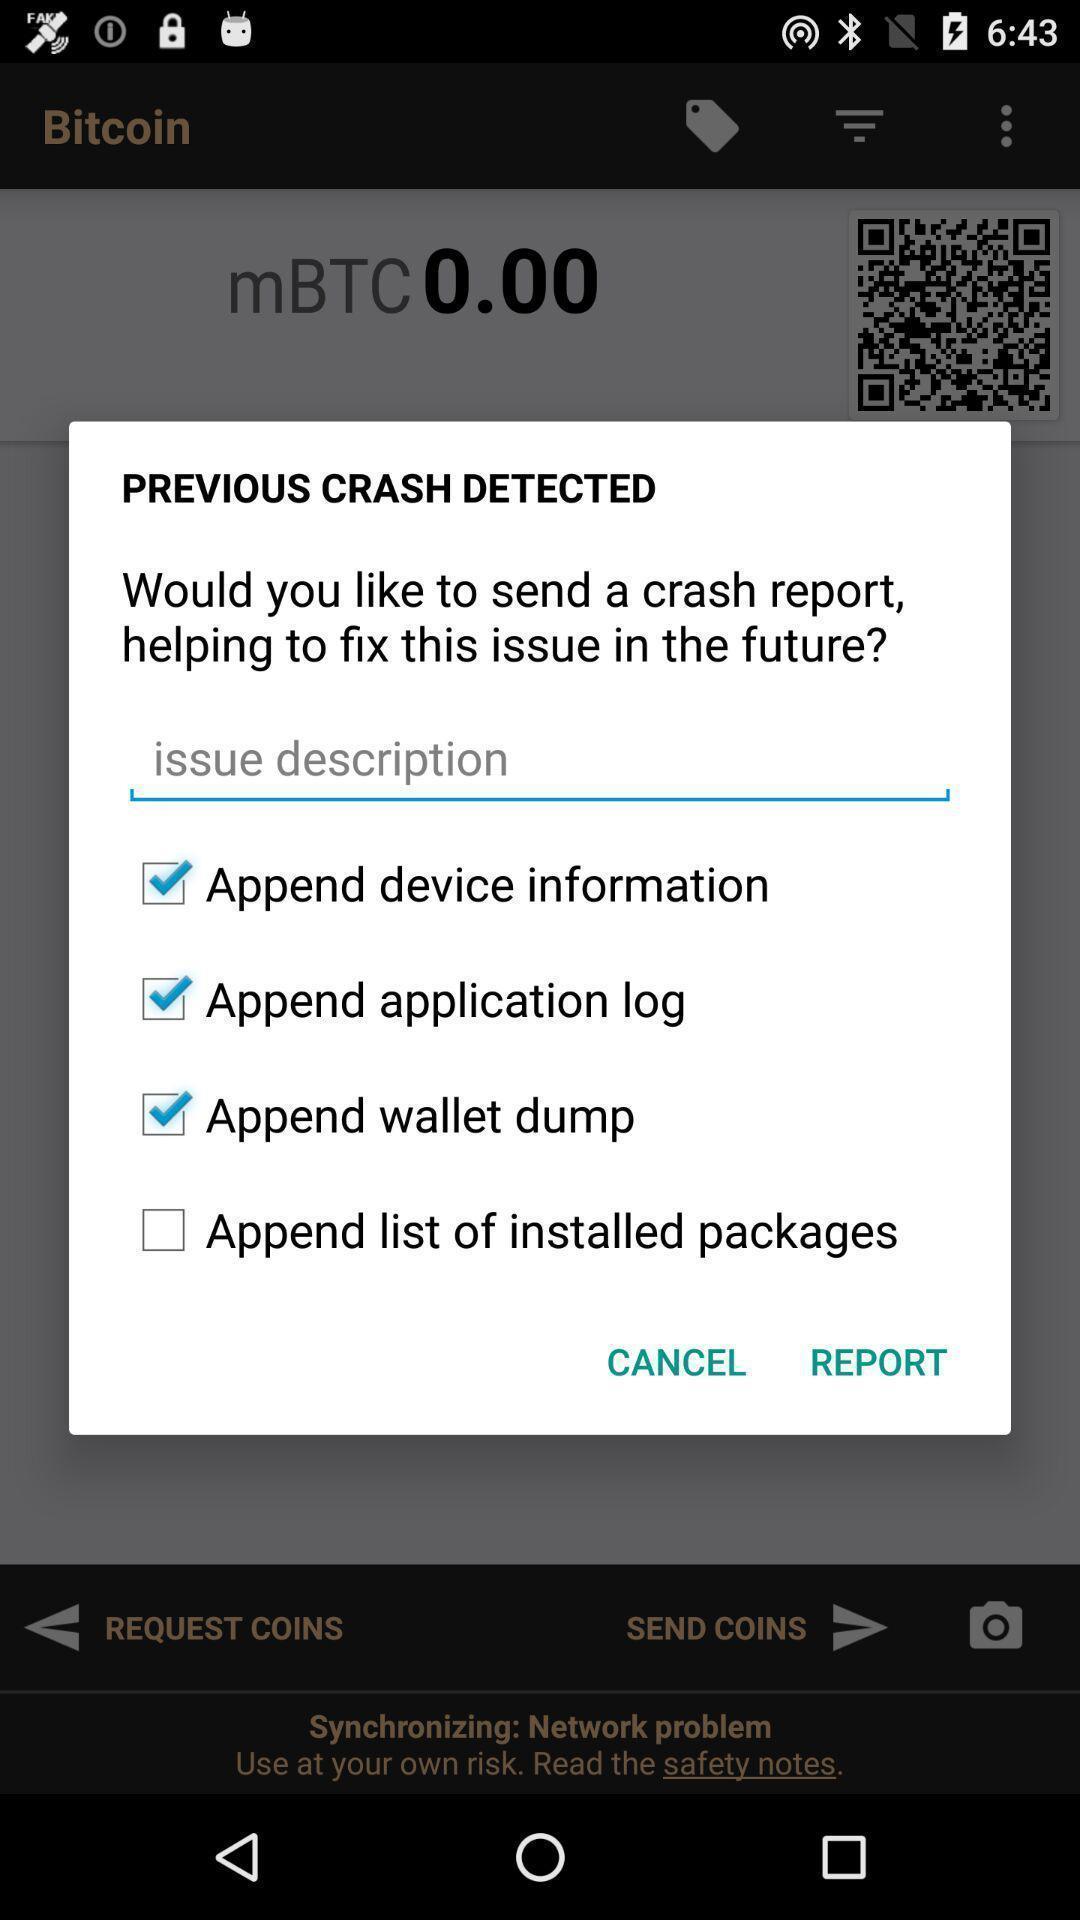Provide a textual representation of this image. Pop-up window showing different options to send reports. 